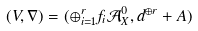Convert formula to latex. <formula><loc_0><loc_0><loc_500><loc_500>( V , \nabla ) = ( \oplus _ { i = 1 } ^ { r } f _ { i } \mathcal { A } ^ { 0 } _ { X } , d ^ { \oplus r } + A )</formula> 